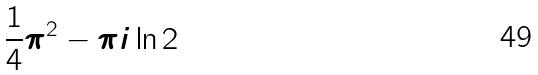Convert formula to latex. <formula><loc_0><loc_0><loc_500><loc_500>\frac { 1 } { 4 } \pi ^ { 2 } - \pi i \ln 2</formula> 